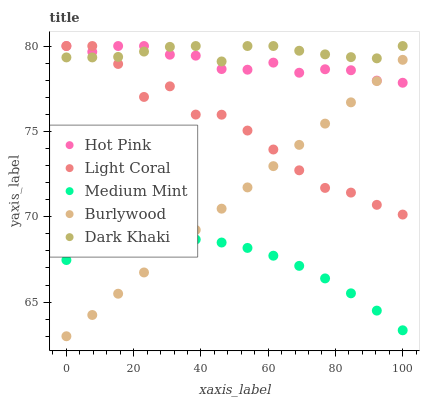Does Medium Mint have the minimum area under the curve?
Answer yes or no. Yes. Does Dark Khaki have the maximum area under the curve?
Answer yes or no. Yes. Does Hot Pink have the minimum area under the curve?
Answer yes or no. No. Does Hot Pink have the maximum area under the curve?
Answer yes or no. No. Is Burlywood the smoothest?
Answer yes or no. Yes. Is Light Coral the roughest?
Answer yes or no. Yes. Is Medium Mint the smoothest?
Answer yes or no. No. Is Medium Mint the roughest?
Answer yes or no. No. Does Burlywood have the lowest value?
Answer yes or no. Yes. Does Medium Mint have the lowest value?
Answer yes or no. No. Does Dark Khaki have the highest value?
Answer yes or no. Yes. Does Medium Mint have the highest value?
Answer yes or no. No. Is Medium Mint less than Hot Pink?
Answer yes or no. Yes. Is Dark Khaki greater than Medium Mint?
Answer yes or no. Yes. Does Burlywood intersect Light Coral?
Answer yes or no. Yes. Is Burlywood less than Light Coral?
Answer yes or no. No. Is Burlywood greater than Light Coral?
Answer yes or no. No. Does Medium Mint intersect Hot Pink?
Answer yes or no. No. 